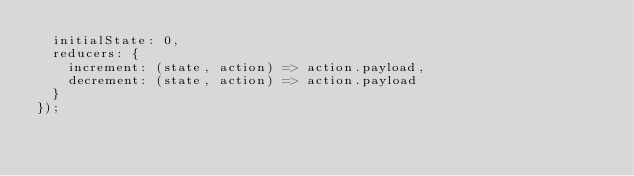Convert code to text. <code><loc_0><loc_0><loc_500><loc_500><_JavaScript_>  initialState: 0,
  reducers: {
    increment: (state, action) => action.payload,
    decrement: (state, action) => action.payload
  }
});
</code> 